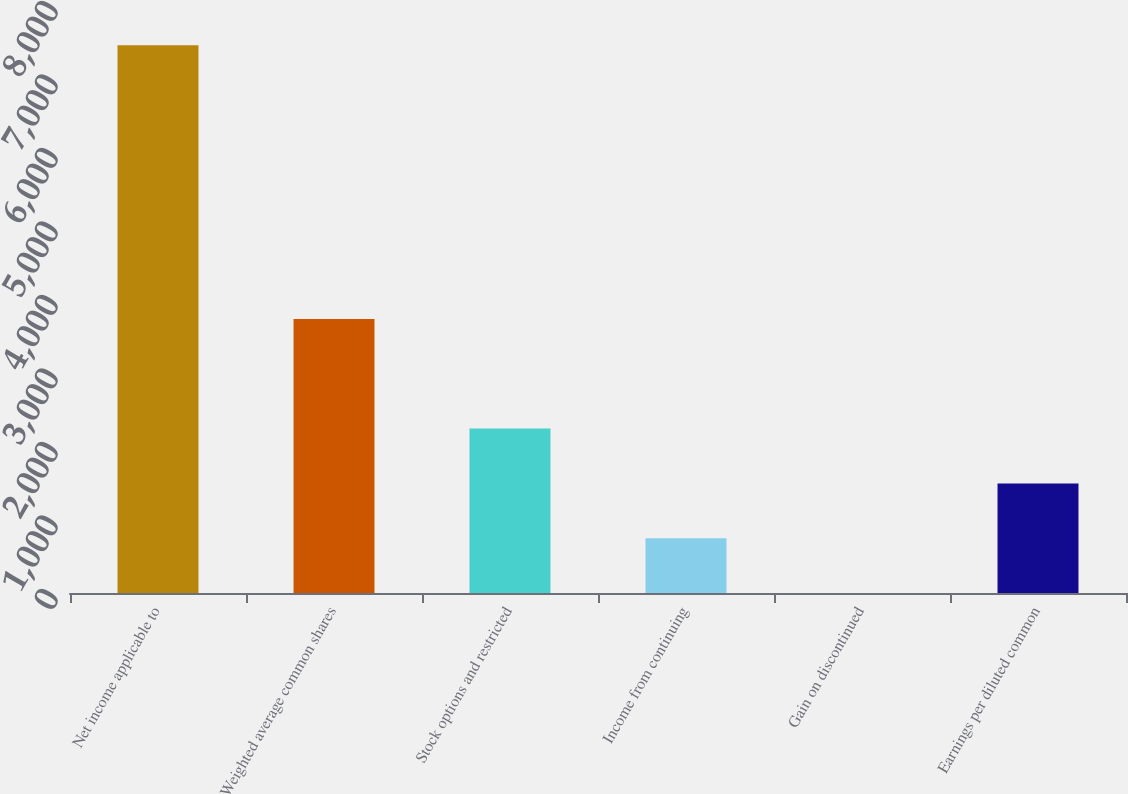<chart> <loc_0><loc_0><loc_500><loc_500><bar_chart><fcel>Net income applicable to<fcel>Weighted average common shares<fcel>Stock options and restricted<fcel>Income from continuing<fcel>Gain on discontinued<fcel>Earnings per diluted common<nl><fcel>7453<fcel>3727.03<fcel>2236.65<fcel>746.27<fcel>1.08<fcel>1491.46<nl></chart> 